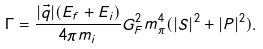Convert formula to latex. <formula><loc_0><loc_0><loc_500><loc_500>\Gamma = \frac { | \vec { q } | ( E _ { f } + E _ { i } ) } { 4 \pi m _ { i } } G ^ { 2 } _ { F } m ^ { 4 } _ { \pi } ( | S | ^ { 2 } + | P | ^ { 2 } ) .</formula> 